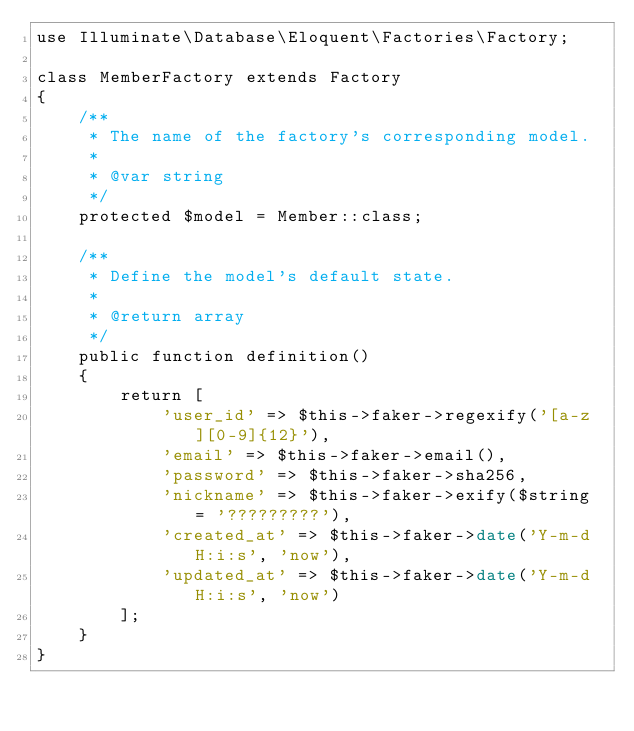<code> <loc_0><loc_0><loc_500><loc_500><_PHP_>use Illuminate\Database\Eloquent\Factories\Factory;

class MemberFactory extends Factory
{
    /**
     * The name of the factory's corresponding model.
     *
     * @var string
     */
    protected $model = Member::class;

    /**
     * Define the model's default state.
     *
     * @return array
     */
    public function definition()
    {
        return [
            'user_id' => $this->faker->regexify('[a-z][0-9]{12}'),
            'email' => $this->faker->email(),
            'password' => $this->faker->sha256,
            'nickname' => $this->faker->exify($string = '?????????'),
            'created_at' => $this->faker->date('Y-m-d H:i:s', 'now'),
            'updated_at' => $this->faker->date('Y-m-d H:i:s', 'now')
        ];
    }
}
</code> 